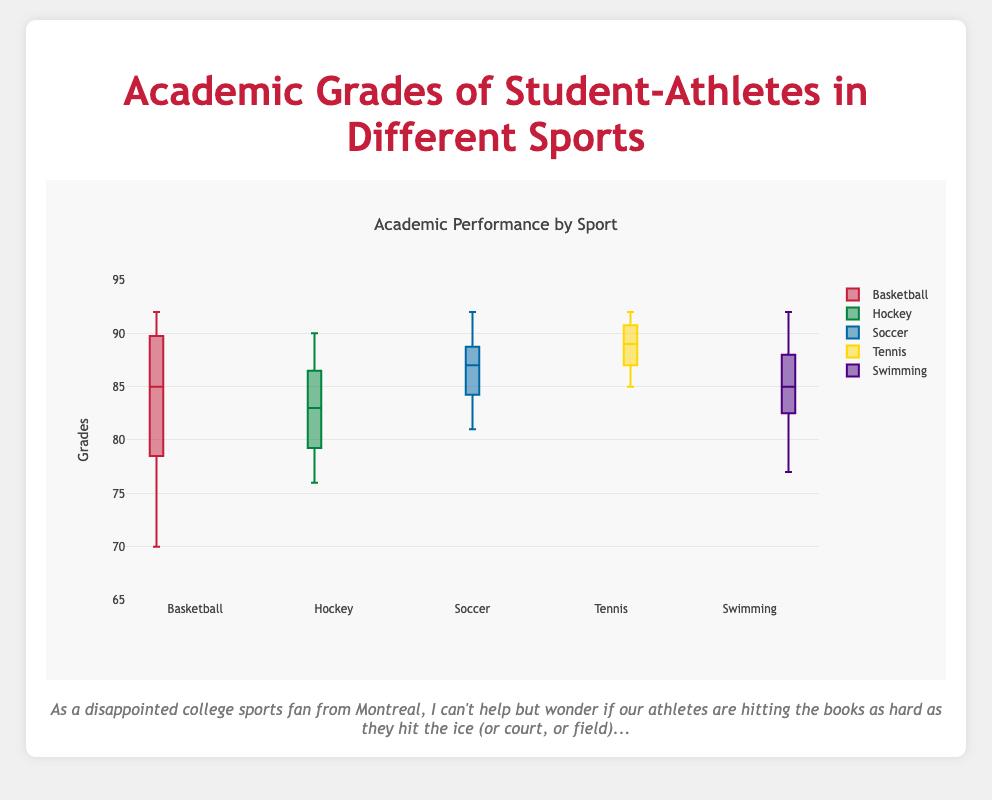What's the range of grades for Basketball? The range is calculated by subtracting the minimum grade from the maximum grade. For Basketball, the minimum grade is 70 and the maximum grade is 92. Thus, the range is 92 - 70 = 22.
Answer: 22 Which sport has the highest median grade? The median is the middle value when the grades are ordered. From the box plot, Tennis has the highest median grade.
Answer: Tennis What is the interquartile range (IQR) of Soccer grades? The IQR is the difference between the third quartile (Q3) and the first quartile (Q1). From the box plot, Q3 for Soccer is around 90 and Q1 is around 84. Thus, the IQR is 90 - 84 = 6.
Answer: 6 How does the median grade of Hockey compare to that of Basketball? The median grade for Hockey is around 83, while the median for Basketball is slightly higher at around 85. Thus, the median grade of Hockey is less than that of Basketball.
Answer: Hockey < Basketball Which sport has the smallest range of grades? The range is the difference between the maximum and minimum values. Referring to the box plot, Tennis has the smallest range as the grades are tightly clustered between 85 and 92, making the range 92 - 85 = 7.
Answer: Tennis What are the whiskers in the box plot for Swimming indicating? The whiskers extend to the minimum and maximum grades within 1.5 IQR from the lower and upper quartiles, respectively. For Swimming, the whiskers indicate the spread of grades from approximately 77 to 92.
Answer: 77 to 92 For which sport is the upper quartile (Q3) higher: Soccer or Hockey? The upper quartile (Q3) represents the value below which 75% of the data falls. From the box plot, Q3 for Soccer is approximately 90, which is higher than that of Hockey (around 87).
Answer: Soccer Which sport shows the widest interquartile range (IQR)? The IQR is the distance between Q1 and Q3. From the box plot, Basketball has the widest IQR, indicating a greater spread of grades between the first and third quartiles.
Answer: Basketball Are there any sports where the grades include below 75? Yes, for Basketball, the lowest grade is 70, which is below 75.
Answer: Basketball 